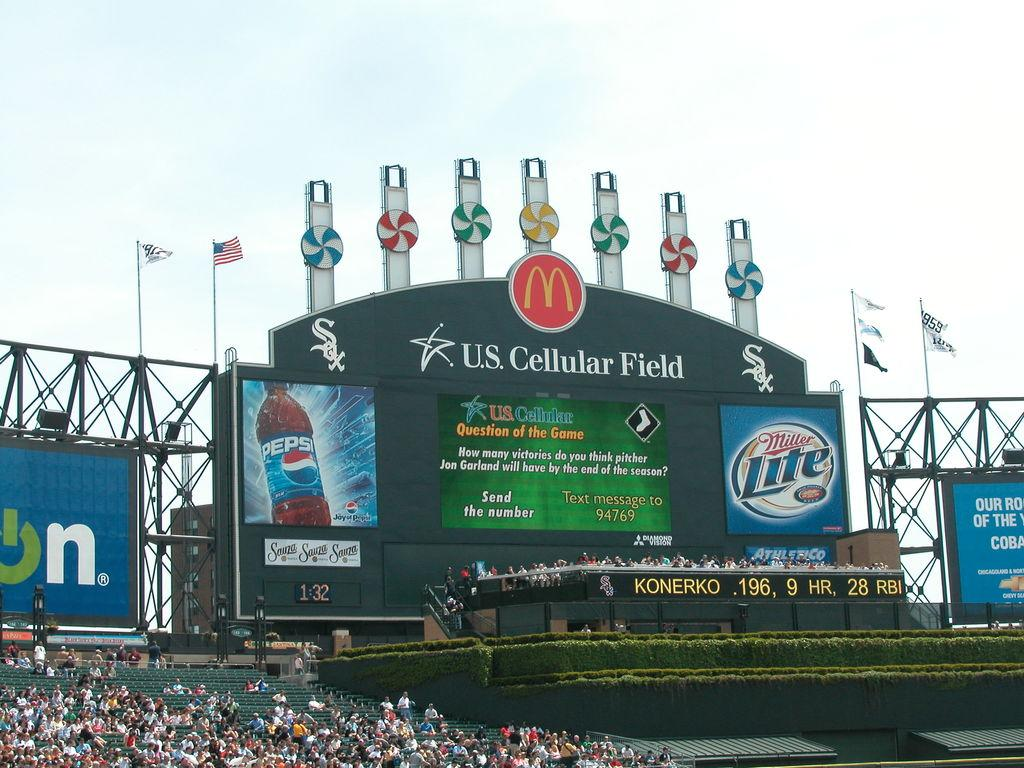<image>
Provide a brief description of the given image. A sports event is taking place at the U.S. Cellular Field. 